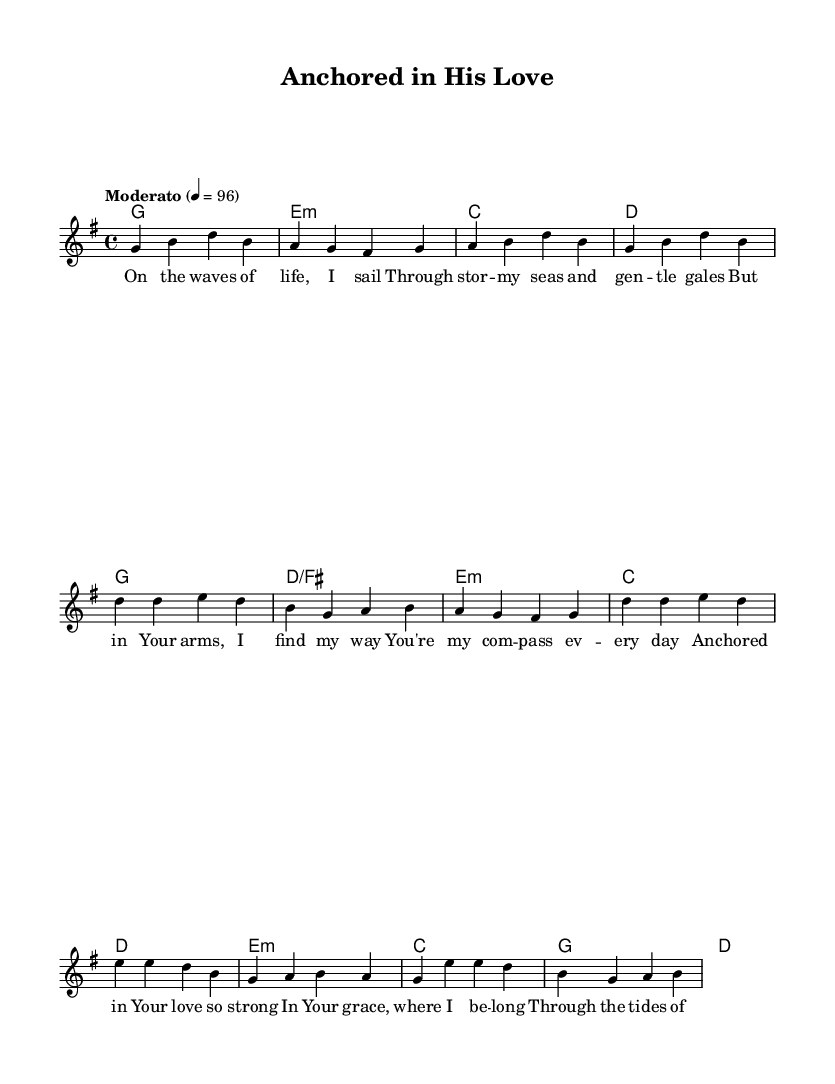What is the key signature of this music? The key signature indicated is G major, which has one sharp (F#).
Answer: G major What is the time signature of this piece? The time signature shown is 4/4, meaning there are four beats in each measure.
Answer: 4/4 What is the tempo marking of this piece? The tempo marking states "Moderato," which typically indicates a moderate pace. The metronome marking of 4 = 96 shows the beats per minute.
Answer: Moderato How many verses are in the song? The structure of the song includes one verse, followed by a chorus, and a bridge, suggesting there is one main verse.
Answer: One Which lyric reflects a sense of safety? The lyric "Safe in Your eternity," in the chorus, conveys a feeling of being secure and protected.
Answer: Safe in Your eternity What is the first line of the bridge? The first line of the bridge reads, "In the depths of Your mercy," which introduces a theme of divine compassion.
Answer: In the depths of Your mercy How many different sections are there in the song? The song is structured into three distinct sections: a verse, a chorus, and a bridge.
Answer: Three 